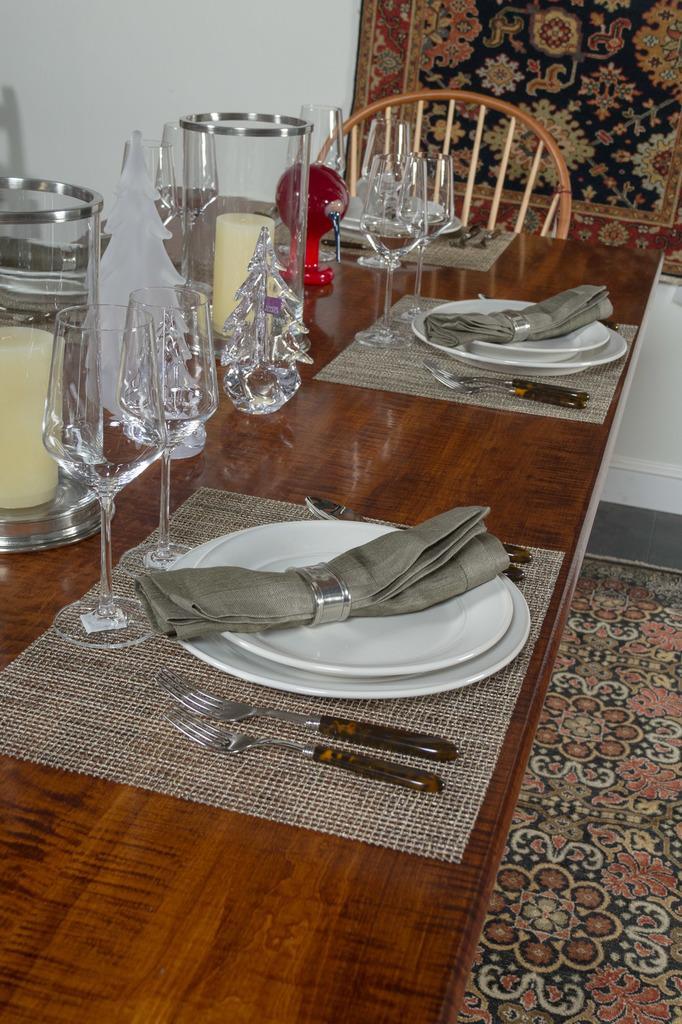In one or two sentences, can you explain what this image depicts? In this image I can see a table. On table there is a cloth,fork,two plates glasses spoon candle in a chair. There is some object made with a glass. On the floor there is a floor mat. The background is in white color. 